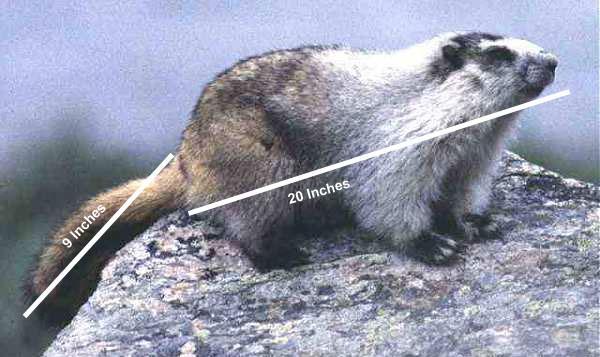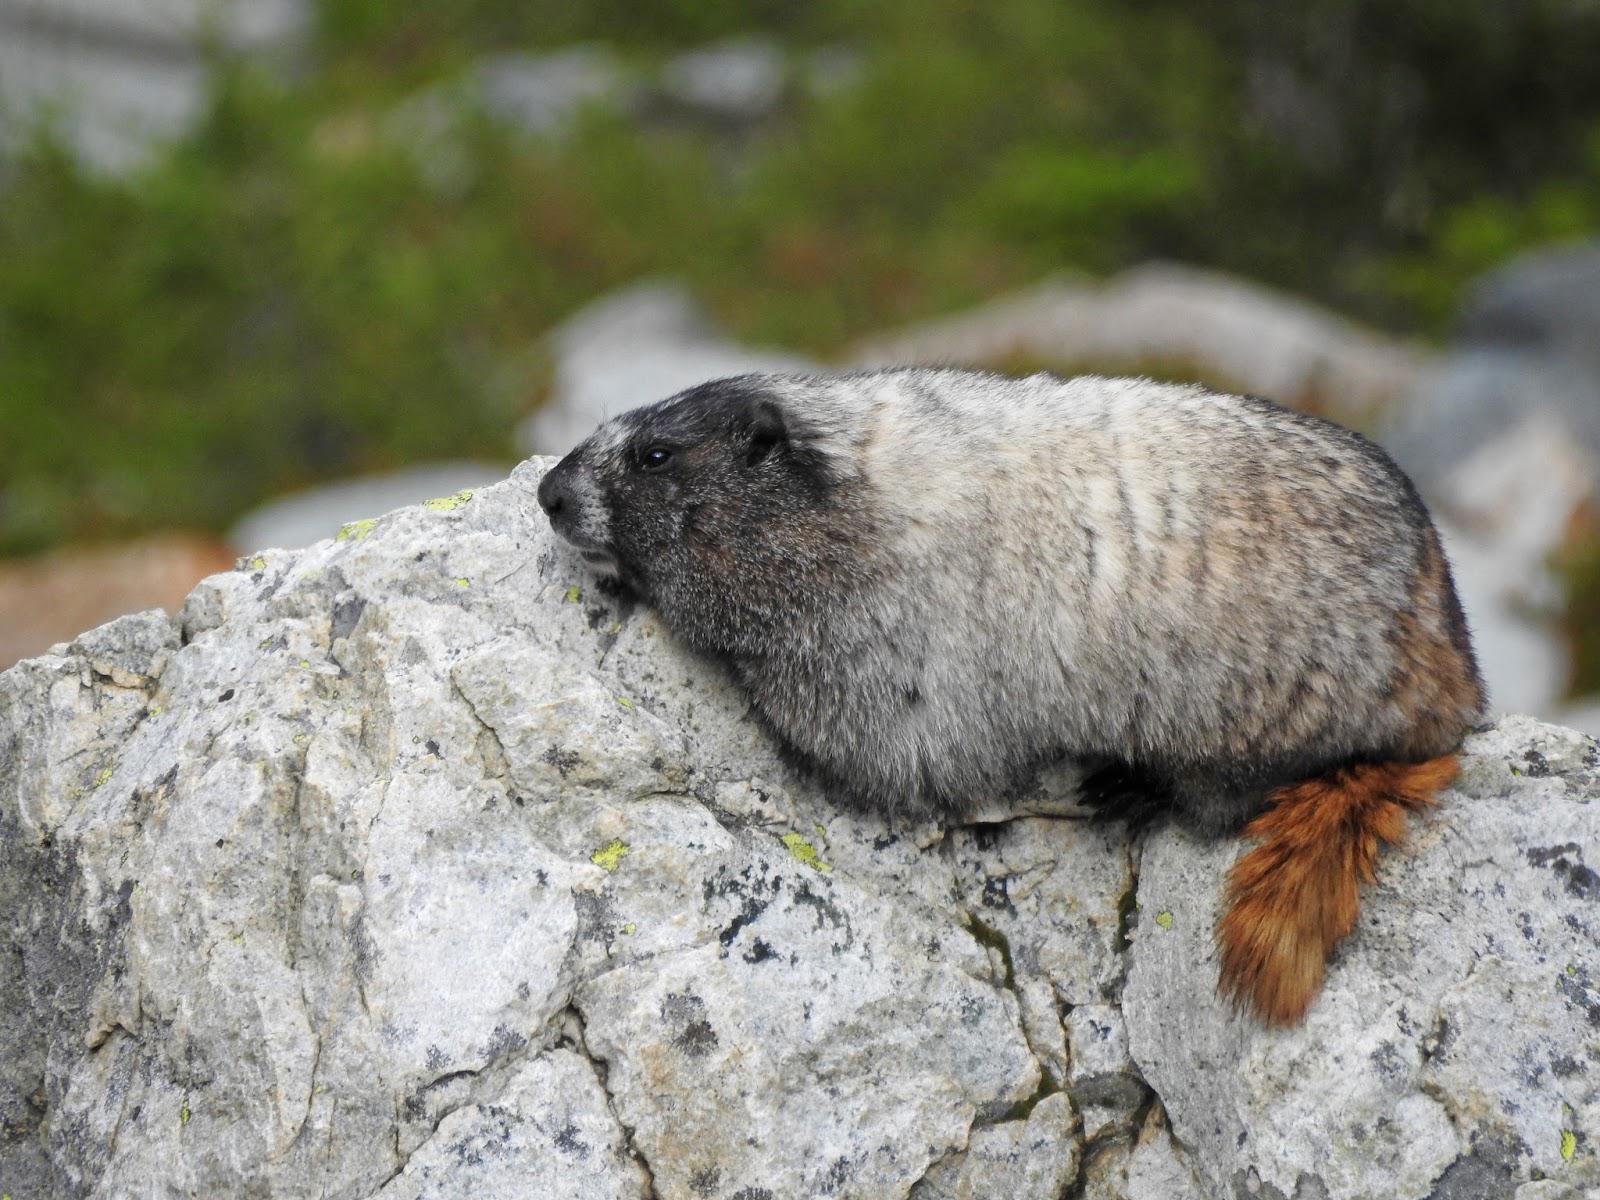The first image is the image on the left, the second image is the image on the right. Examine the images to the left and right. Is the description "The right image contains one small animal facing leftward, with its body flat on a rock and its brown tail angled downward." accurate? Answer yes or no. Yes. The first image is the image on the left, the second image is the image on the right. For the images displayed, is the sentence "the left and right image contains the same number of prairie dogs with long brown tales." factually correct? Answer yes or no. Yes. 